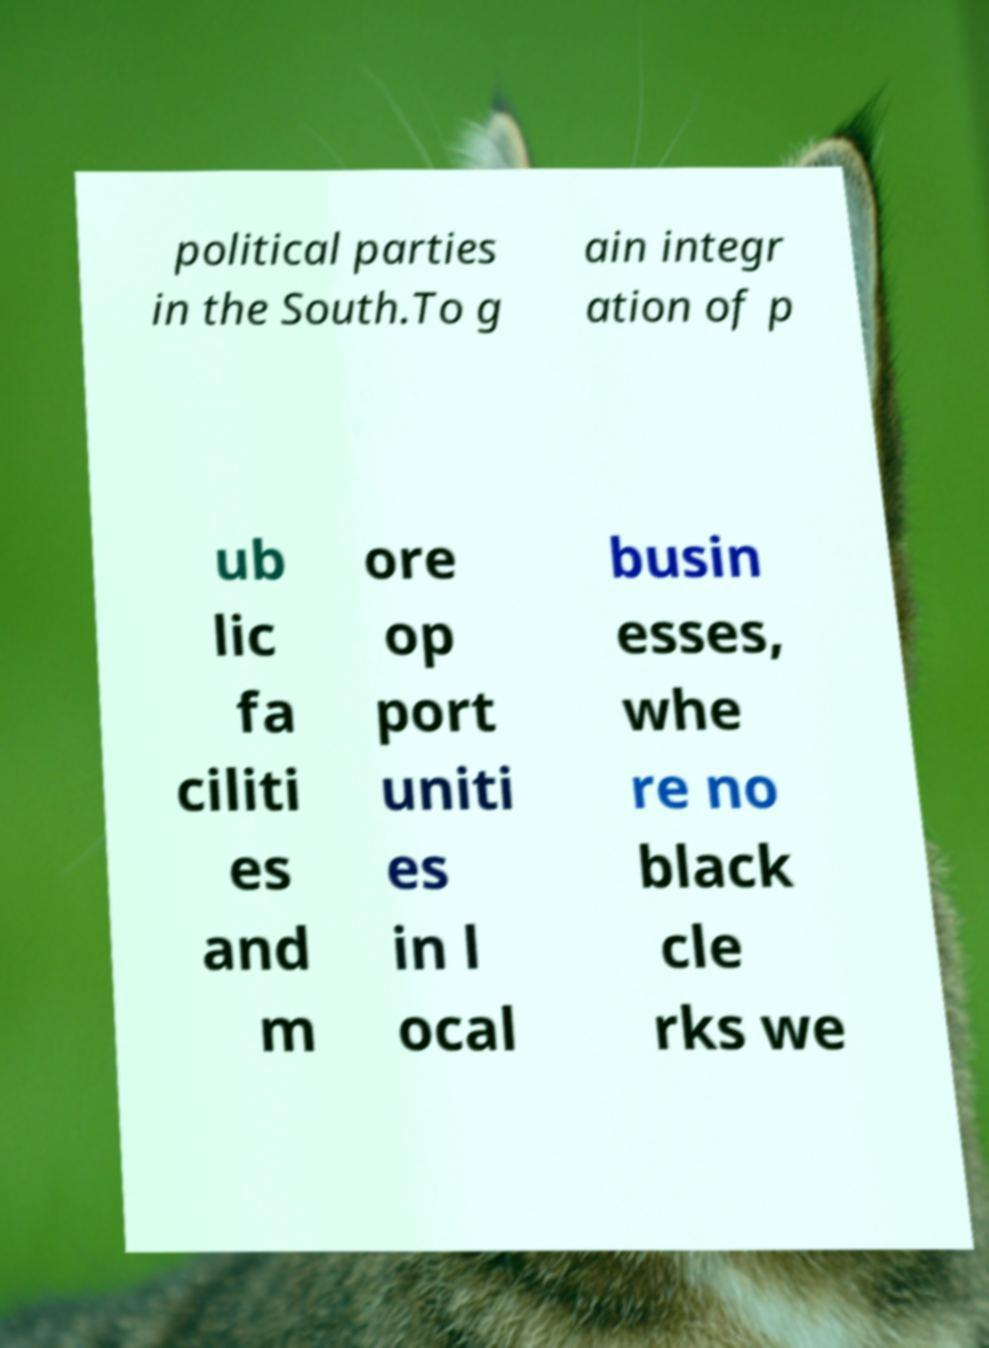What messages or text are displayed in this image? I need them in a readable, typed format. political parties in the South.To g ain integr ation of p ub lic fa ciliti es and m ore op port uniti es in l ocal busin esses, whe re no black cle rks we 